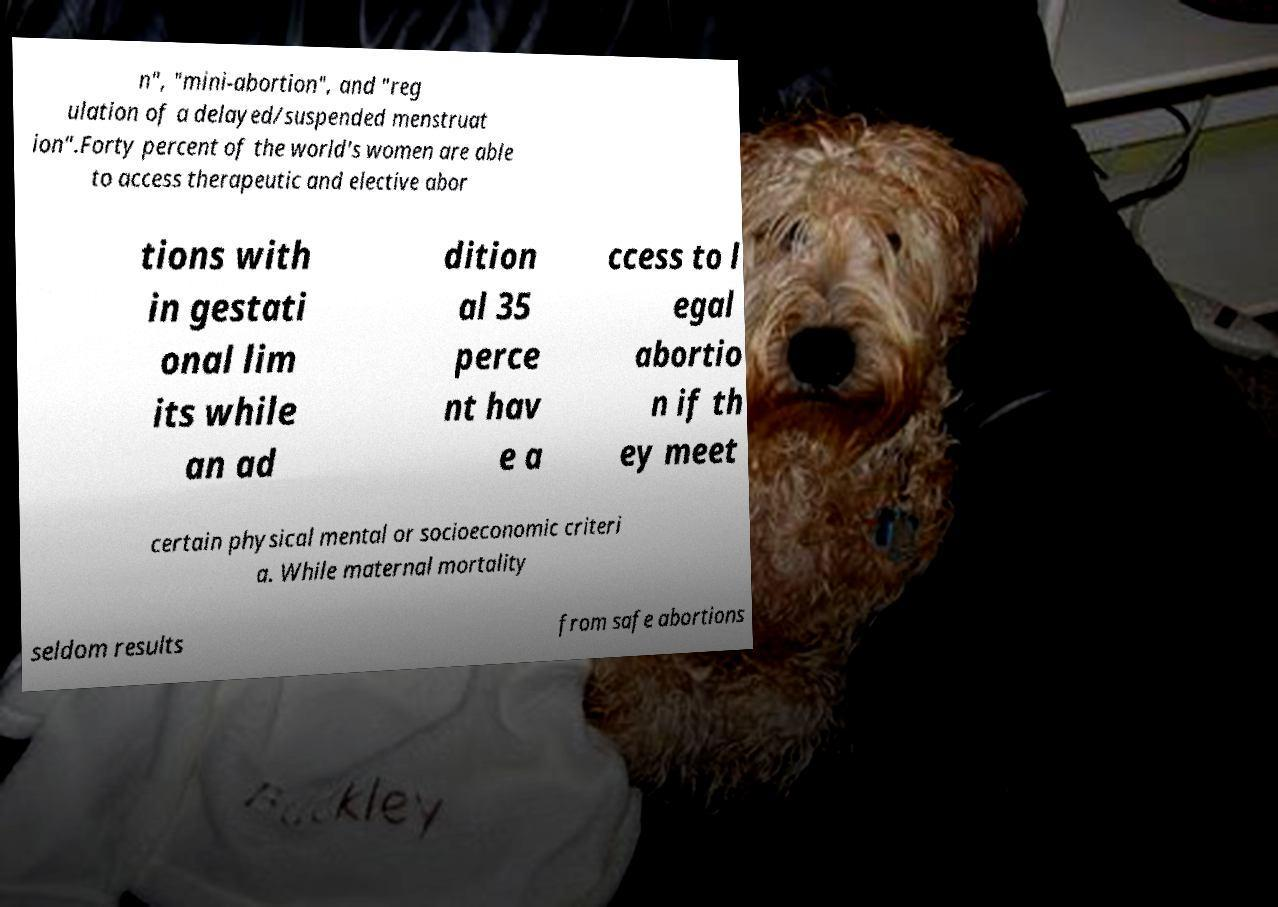Please read and relay the text visible in this image. What does it say? n", "mini-abortion", and "reg ulation of a delayed/suspended menstruat ion".Forty percent of the world's women are able to access therapeutic and elective abor tions with in gestati onal lim its while an ad dition al 35 perce nt hav e a ccess to l egal abortio n if th ey meet certain physical mental or socioeconomic criteri a. While maternal mortality seldom results from safe abortions 